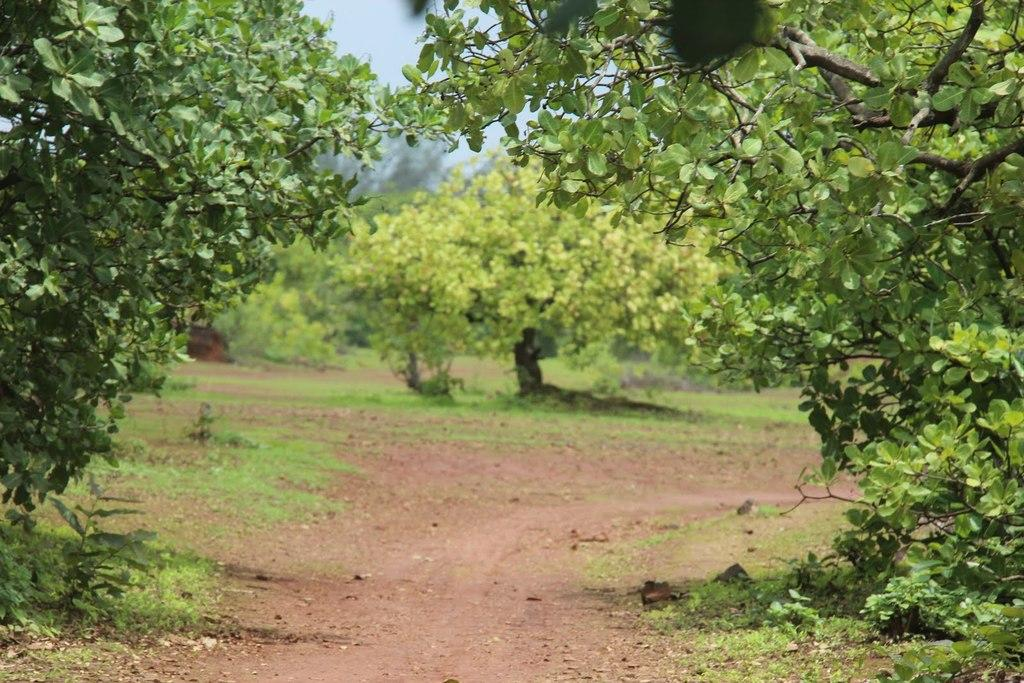What can be seen underfoot in the image? The ground is visible in the image. What type of vegetation is present on the ground? There is grass in the image. What other types of vegetation can be seen in the image? Plants are present in the image. What is the setting of the image? Trees are on either side of the image, and the background is slightly blurred. What can be seen in the distance in the image? The sky is visible in the background of the image. How many leaves does the duck on the tree have in the image? There is no duck present in the image, and therefore no leaves on a duck can be observed. 